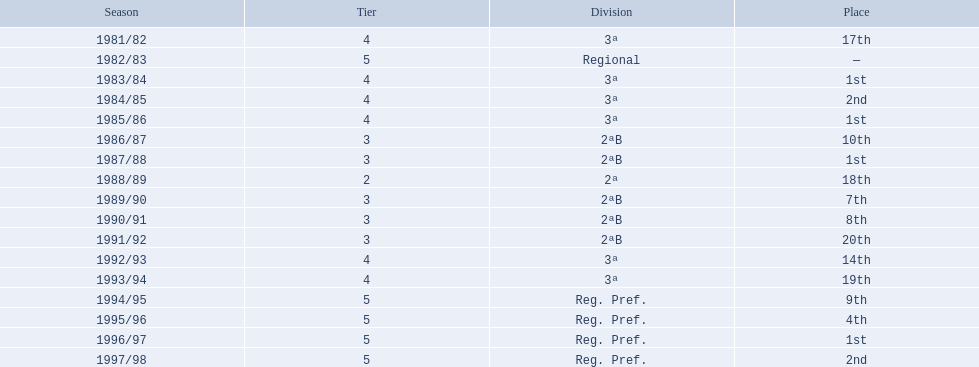In which years did the team rank 17th or lower? 1981/82, 1988/89, 1991/92, 1993/94. Out of those, which year had the worst performance? 1991/92. 